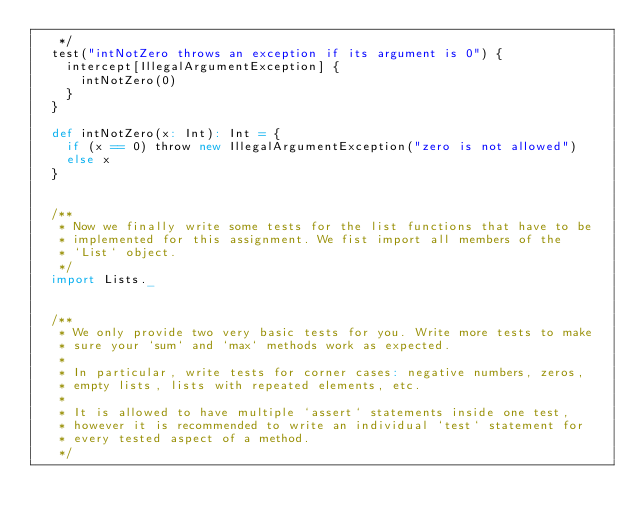<code> <loc_0><loc_0><loc_500><loc_500><_Scala_>   */
  test("intNotZero throws an exception if its argument is 0") {
    intercept[IllegalArgumentException] {
      intNotZero(0)
    }
  }

  def intNotZero(x: Int): Int = {
    if (x == 0) throw new IllegalArgumentException("zero is not allowed")
    else x
  }


  /**
   * Now we finally write some tests for the list functions that have to be
   * implemented for this assignment. We fist import all members of the
   * `List` object.
   */ 
  import Lists._
  

  /**
   * We only provide two very basic tests for you. Write more tests to make
   * sure your `sum` and `max` methods work as expected.
   *
   * In particular, write tests for corner cases: negative numbers, zeros,
   * empty lists, lists with repeated elements, etc.
   *
   * It is allowed to have multiple `assert` statements inside one test,
   * however it is recommended to write an individual `test` statement for
   * every tested aspect of a method.
   */</code> 